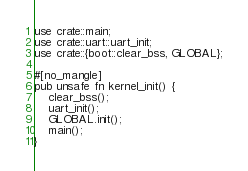<code> <loc_0><loc_0><loc_500><loc_500><_Rust_>use crate::main;
use crate::uart::uart_init;
use crate::{boot::clear_bss, GLOBAL};

#[no_mangle]
pub unsafe fn kernel_init() {
    clear_bss();
    uart_init();
    GLOBAL.init();
    main();
}
</code> 